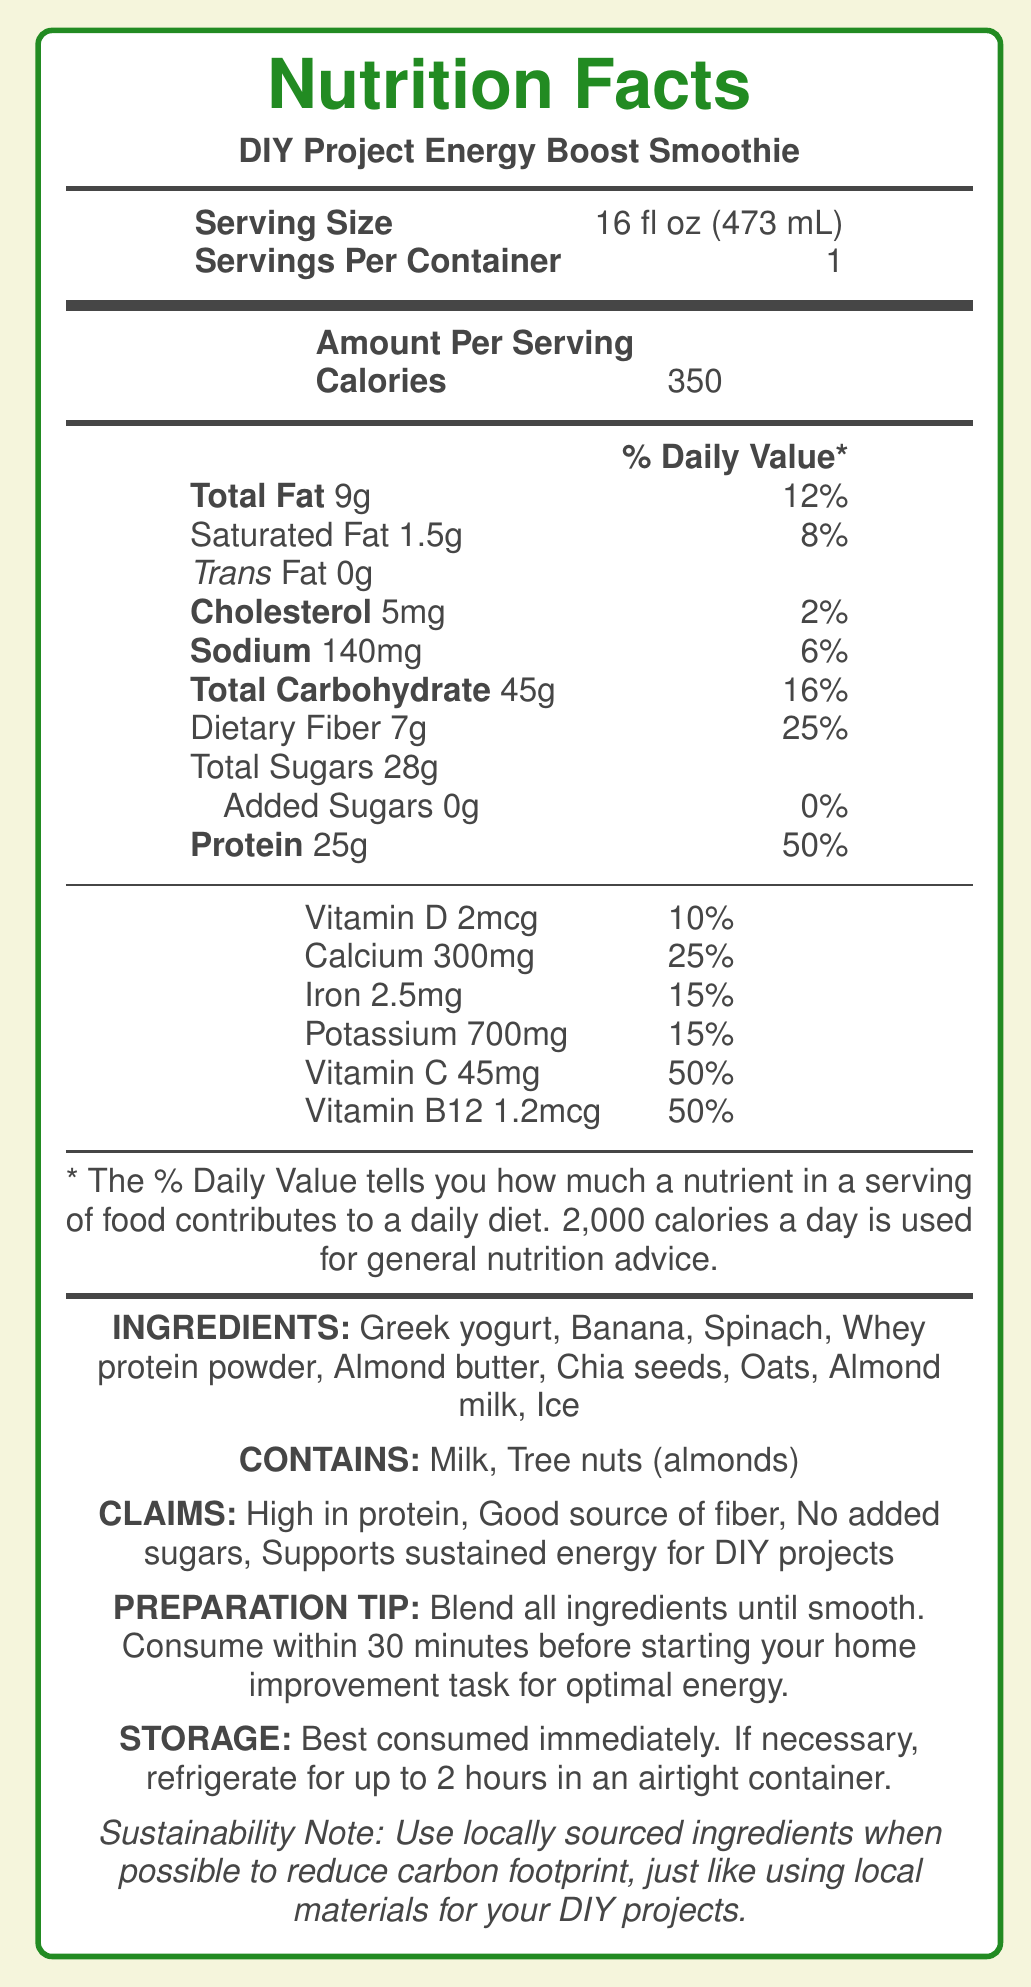what is the serving size of the DIY Project Energy Boost Smoothie? The serving size is mentioned explicitly as 16 fl oz (473 mL) in the document.
Answer: 16 fl oz (473 mL) how many calories are in one serving of the smoothie? The document lists the calories per serving as 350.
Answer: 350 what ingredient list does the smoothie contain? The ingredients are listed in the document under the "INGREDIENTS" section.
Answer: Greek yogurt, Banana, Spinach, Whey protein powder, Almond butter, Chia seeds, Oats, Almond milk, Ice how much protein does one serving provide? The document indicates that one serving contains 25g of protein.
Answer: 25g what % of the daily value does the dietary fiber in this smoothie fulfill? The dietary fiber in one serving satisfies 25% of the daily value, as per the document.
Answer: 25% does the smoothie contain any added sugars? The document states that there are 0g of added sugars.
Answer: No which allergens are present in the smoothie? A. Peanuts B. Milk C. Wheat D. Soy The allergens listed are Milk and Tree nuts (almonds), so correct answer is B.
Answer: B how long can you store the smoothie once prepared? A. Best consumed immediately B. Up to 1 hour C. Up to 2 hours D. Up to 24 hours The document specifies that the smoothie should be consumed immediately but can be refrigerated for up to 2 hours.
Answer: C is the DIY Project Energy Boost Smoothie high in protein? The document claims that the smoothie is high in protein.
Answer: Yes what is the recommended timing for consuming the smoothie for optimal energy during DIY projects? The preparation tip suggests consuming the smoothie within 30 minutes before starting the task.
Answer: Within 30 minutes before starting your home improvement task how does the smoothie support sustainability practices? The document notes that using locally sourced ingredients can help reduce the carbon footprint.
Answer: Use locally sourced ingredients when possible to reduce carbon footprint what is the main idea of the DIY Project Energy Boost Smoothie nutrition facts label? The document covers various aspects including nutritional values, ingredients, claims, preparation tips, and storage, focusing on providing energy for DIY projects.
Answer: The document provides detailed nutritional information for the DIY Project Energy Boost Smoothie, highlighting its high protein content, fiber source, and suitability for sustained energy during DIY projects. It includes ingredients, allergens, preparation tips, storage instructions, and a sustainability note. how many types of sugar does the smoothie contain? The document specifies only "Total Sugars" amounting to 28g and indicates no added sugars.
Answer: One, total sugars which relevant vitamins and minerals are included in the smoothie? The document lists these specific vitamins and minerals under their respective sections.
Answer: Vitamin D, Calcium, Iron, Potassium, Vitamin C, Vitamin B12 what is the daily value percentage of sodium in the smoothie? The document states the sodium content and its daily value percentage as 140mg and 6%, respectively.
Answer: 6% does the smoothie contain any whey protein? The ingredient list in the document includes whey protein powder.
Answer: Yes how much Vitamin C does the smoothie contain and what percentage of the daily value does it contribute? The smoothie contains 45mg of Vitamin C, contributing to 50% of the daily value.
Answer: 45mg and 50% is Greek yogurt one of the ingredients in the DIY Project Energy Boost Smoothie? The document lists Greek yogurt as one of the ingredients.
Answer: Yes what is the suggested preparation method for the smoothie to maximize energy for home improvement tasks? The preparation tip provides this specific method for optimal energy benefits.
Answer: Blend all ingredients until smooth. Consume within 30 minutes before starting your home improvement task for optimal energy. does the document specify the total cost of preparing the smoothie? The document does not provide any information regarding the cost.
Answer: Not enough information what are the Health Claims made for the smoothie? These health claims are explicitly mentioned in the document's claims section.
Answer: High in protein, Good source of fiber, No added sugars, Supports sustained energy for DIY projects 